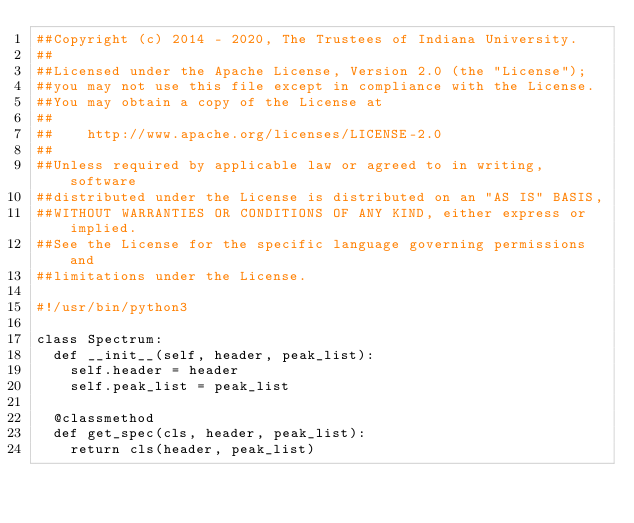<code> <loc_0><loc_0><loc_500><loc_500><_Python_>##Copyright (c) 2014 - 2020, The Trustees of Indiana University.
##
##Licensed under the Apache License, Version 2.0 (the "License");
##you may not use this file except in compliance with the License.
##You may obtain a copy of the License at
##
##    http://www.apache.org/licenses/LICENSE-2.0
##
##Unless required by applicable law or agreed to in writing, software
##distributed under the License is distributed on an "AS IS" BASIS,
##WITHOUT WARRANTIES OR CONDITIONS OF ANY KIND, either express or implied.
##See the License for the specific language governing permissions and
##limitations under the License.

#!/usr/bin/python3

class Spectrum:
  def __init__(self, header, peak_list):
    self.header = header
    self.peak_list = peak_list

  @classmethod
  def get_spec(cls, header, peak_list):
    return cls(header, peak_list)</code> 